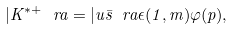Convert formula to latex. <formula><loc_0><loc_0><loc_500><loc_500>| K ^ { * + } \ r a = | u \bar { s } \ r a \epsilon ( 1 , m ) \varphi ( { p } ) ,</formula> 